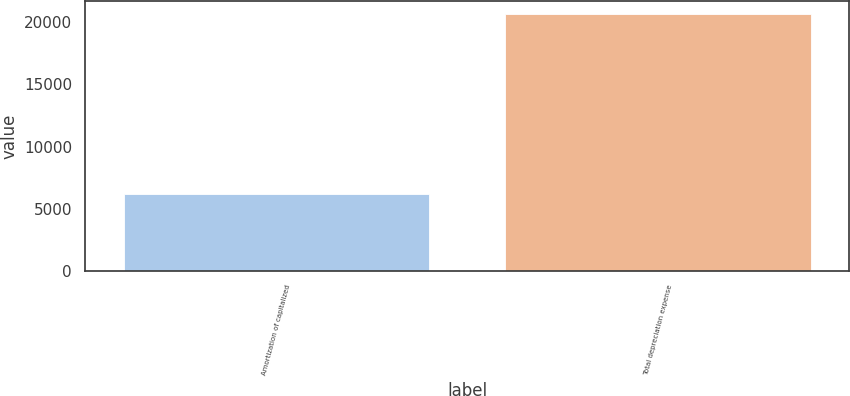Convert chart. <chart><loc_0><loc_0><loc_500><loc_500><bar_chart><fcel>Amortization of capitalized<fcel>Total depreciation expense<nl><fcel>6180<fcel>20680<nl></chart> 